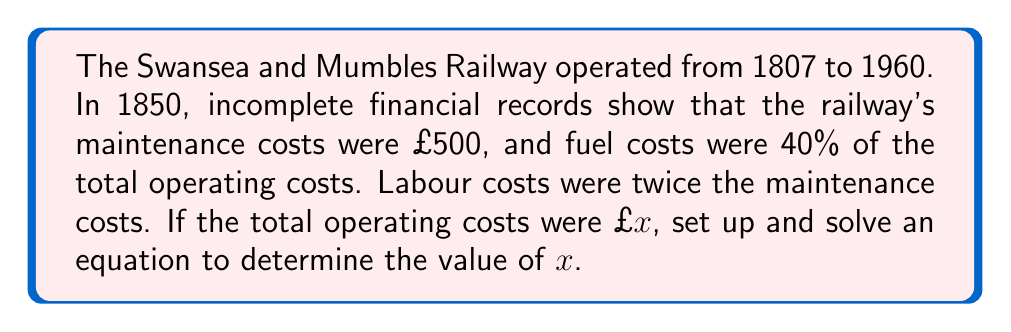Provide a solution to this math problem. Let's approach this step-by-step:

1) Let x be the total operating costs.

2) We know that:
   - Maintenance costs = £500
   - Fuel costs = 40% of total operating costs = 0.4x
   - Labour costs = 2 × Maintenance costs = 2 × £500 = £1000

3) The total operating costs should equal the sum of all individual costs:

   $$x = \text{Maintenance} + \text{Fuel} + \text{Labour}$$

4) Substituting the known values:

   $$x = 500 + 0.4x + 1000$$

5) Simplify:

   $$x = 1500 + 0.4x$$

6) Subtract 0.4x from both sides:

   $$0.6x = 1500$$

7) Divide both sides by 0.6:

   $$x = \frac{1500}{0.6} = 2500$$

Therefore, the total operating costs were £2500.
Answer: £2500 